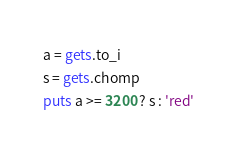<code> <loc_0><loc_0><loc_500><loc_500><_Ruby_>a = gets.to_i
s = gets.chomp
puts a >= 3200 ? s : 'red'</code> 